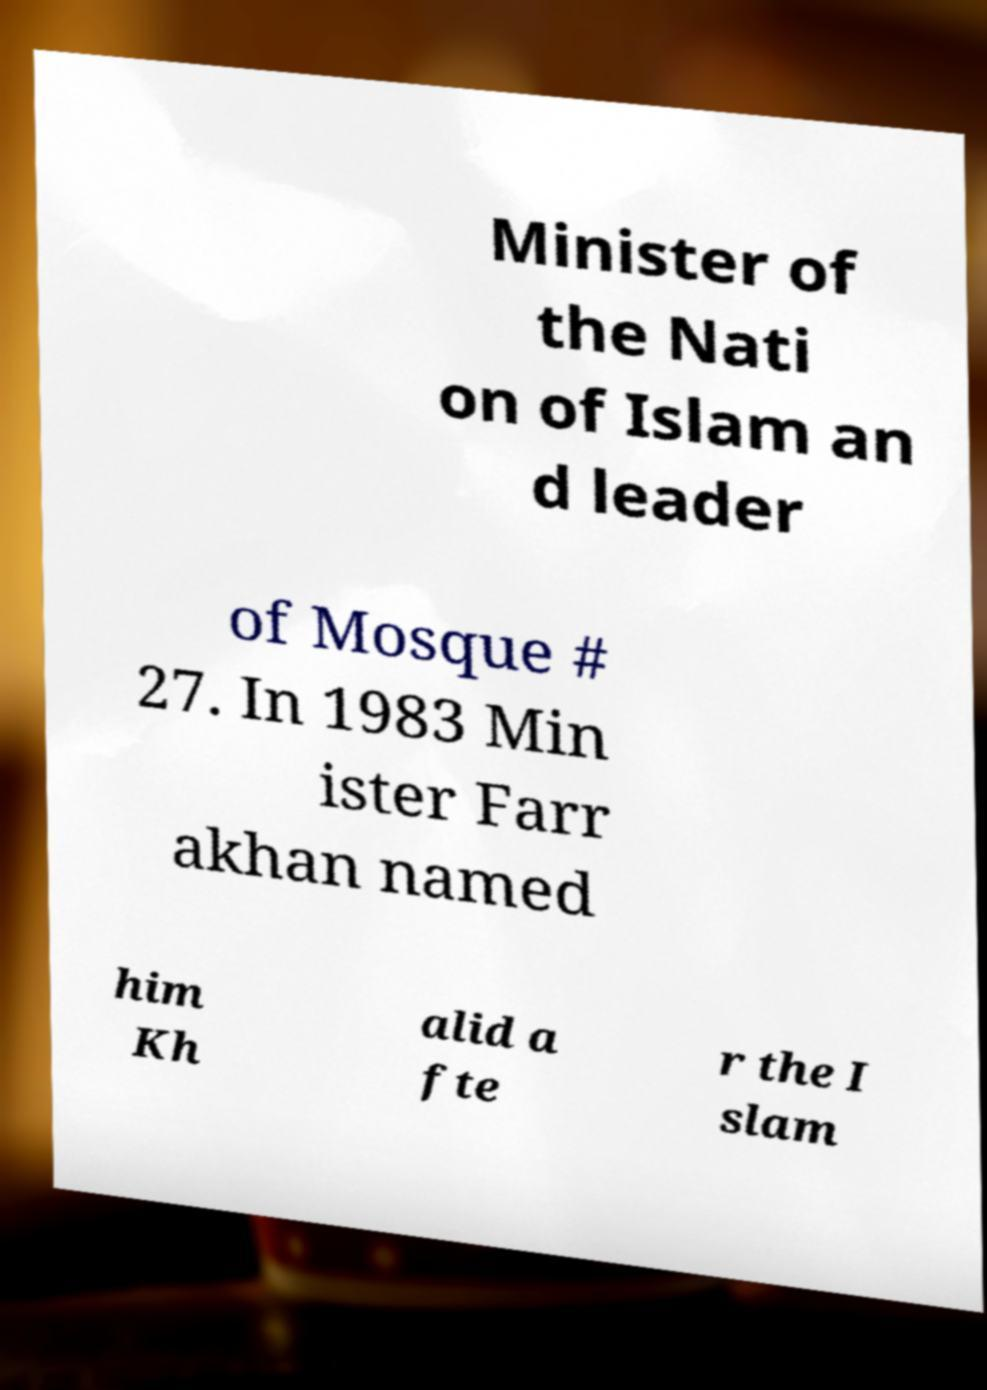Can you accurately transcribe the text from the provided image for me? Minister of the Nati on of Islam an d leader of Mosque # 27. In 1983 Min ister Farr akhan named him Kh alid a fte r the I slam 